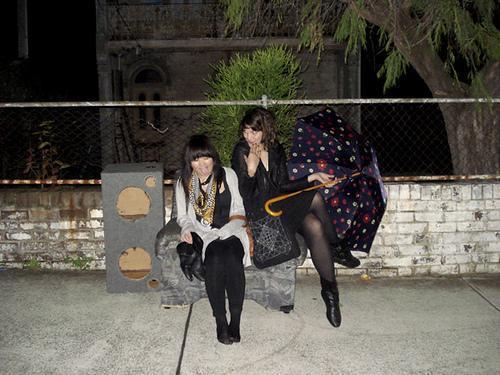How many people are visible?
Give a very brief answer. 2. 